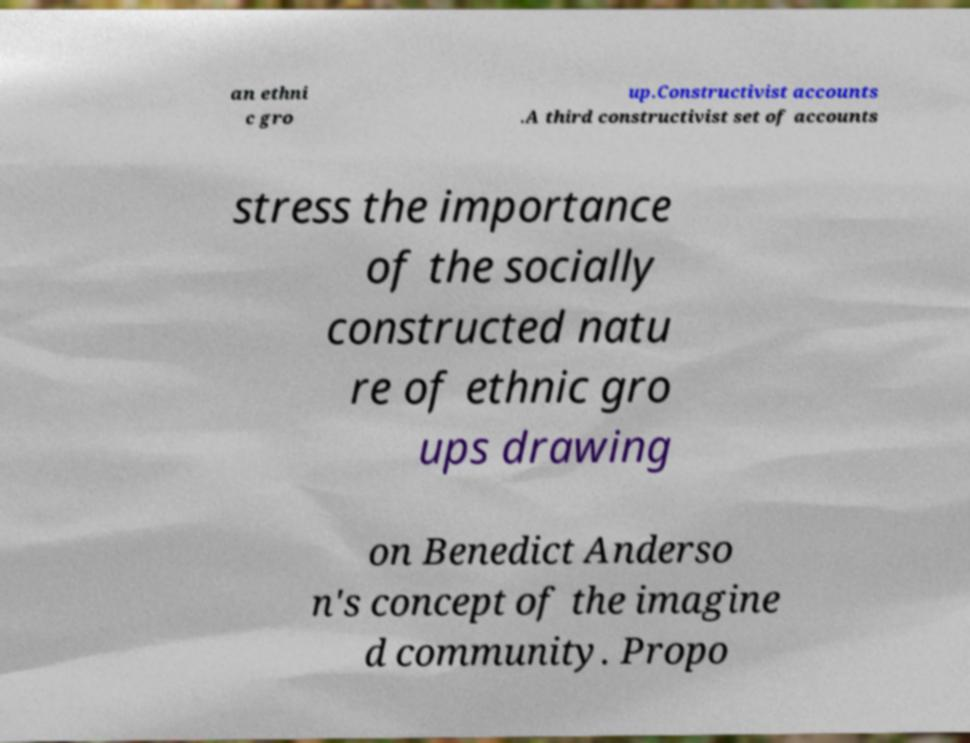Please identify and transcribe the text found in this image. an ethni c gro up.Constructivist accounts .A third constructivist set of accounts stress the importance of the socially constructed natu re of ethnic gro ups drawing on Benedict Anderso n's concept of the imagine d community. Propo 